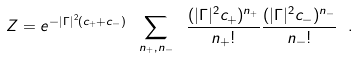<formula> <loc_0><loc_0><loc_500><loc_500>Z = e ^ { - | \Gamma | ^ { 2 } ( c _ { + } + c _ { - } ) } \ \sum _ { n _ { + } , n _ { - } } \ \frac { ( | \Gamma | ^ { 2 } c _ { + } ) ^ { n _ { + } } } { n _ { + } ! } \frac { ( | \Gamma | ^ { 2 } c _ { - } ) ^ { n _ { - } } } { n _ { - } ! } \ .</formula> 